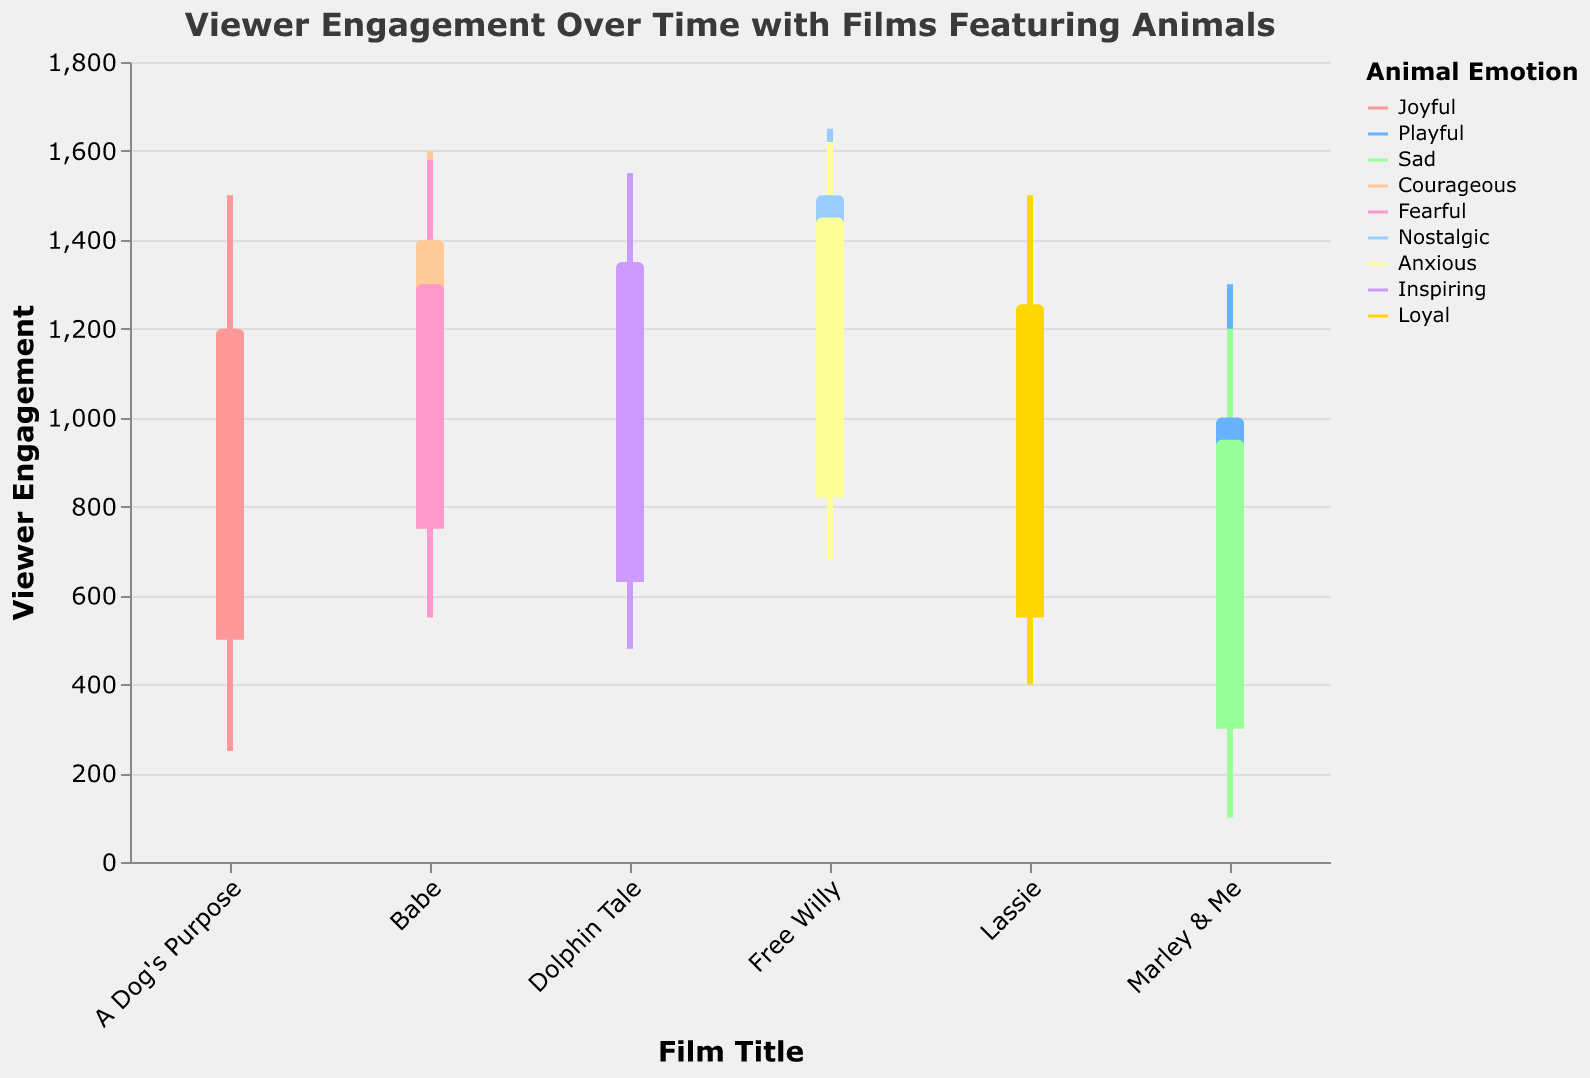What's the highest Viewer Engagement recorded in the scenes presented? The highest viewer engagement can be seen from the "MaxEngagement" values. The "Free Willy" scene has a MaxEngagement of 1650.
Answer: 1650 Which scene in "Marley & Me" shows higher viewer engagement, the one with a Playful or Sad animal emotion? The playful scene has a higher engagement. The "MaxEngagement" for the Playful scene is 1300 while for the Sad scene it is 1200.
Answer: Playful Between "Babe" and "Free Willy", which film shows more viewer engagement in the context of animal's Courageous emotion vs Nostalgic emotion? Comparing the maximum and minimum engagement values for Courageous and Nostalgic emotions, "Free Willy" with Nostalgic emotion has higher max engagement (1650) while "Babe" with Courageous emotion has max engagement of 1600.
Answer: Nostalgic How does viewer engagement change from the beginning to the end of scenes featuring the animal in a "Loyal" emotional state? For "Loyal" emotions in "Lassie", the engagement at start and end of scenes are 550-1250 and 600-1255, respectively. Engagement generally starts moderate and increases but ends around the same level.
Answer: Increases For the film "A Dog's Purpose", what is the difference in viewer engagement between the first and second scene? For scene 1 in "A Dog's Purpose", the end engagement is 1200 while for scene 2 it's 1100. The difference (decrease) is 1200 - 1100 = 100.
Answer: 100 Which film has the least engagement drop between the start and end across all shown scenes? Looking at the end and start engagement values across all films, "Dolphin Tale" has minimal drops. From start 650 to end 1350 in Scene 1, and from start 630 to end 1330 in Scene 2. Drop seems very slight (10-20).
Answer: Dolphin Tale 